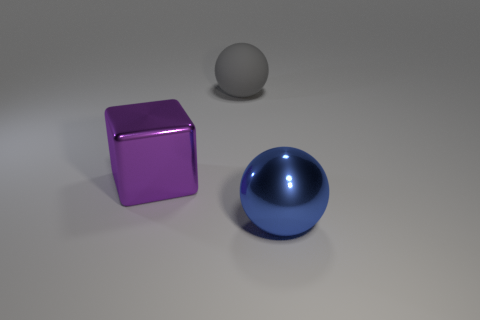Add 3 large purple metal balls. How many objects exist? 6 Subtract all blocks. How many objects are left? 2 Add 1 big yellow things. How many big yellow things exist? 1 Subtract 0 purple cylinders. How many objects are left? 3 Subtract all cylinders. Subtract all large rubber objects. How many objects are left? 2 Add 3 large metallic spheres. How many large metallic spheres are left? 4 